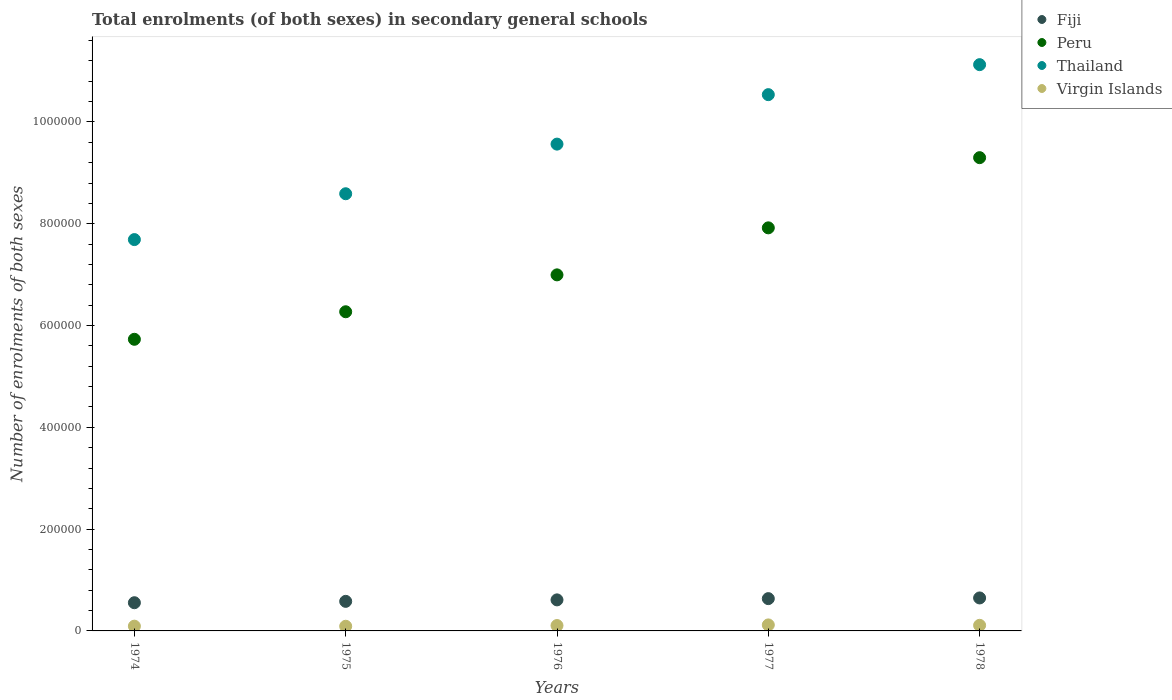How many different coloured dotlines are there?
Provide a succinct answer. 4. Is the number of dotlines equal to the number of legend labels?
Provide a succinct answer. Yes. What is the number of enrolments in secondary schools in Fiji in 1974?
Ensure brevity in your answer.  5.54e+04. Across all years, what is the maximum number of enrolments in secondary schools in Peru?
Your answer should be very brief. 9.30e+05. Across all years, what is the minimum number of enrolments in secondary schools in Peru?
Provide a succinct answer. 5.73e+05. In which year was the number of enrolments in secondary schools in Peru maximum?
Ensure brevity in your answer.  1978. In which year was the number of enrolments in secondary schools in Peru minimum?
Offer a very short reply. 1974. What is the total number of enrolments in secondary schools in Thailand in the graph?
Provide a short and direct response. 4.75e+06. What is the difference between the number of enrolments in secondary schools in Virgin Islands in 1974 and that in 1976?
Give a very brief answer. -1250. What is the difference between the number of enrolments in secondary schools in Virgin Islands in 1978 and the number of enrolments in secondary schools in Peru in 1977?
Provide a succinct answer. -7.81e+05. What is the average number of enrolments in secondary schools in Fiji per year?
Offer a very short reply. 6.05e+04. In the year 1975, what is the difference between the number of enrolments in secondary schools in Fiji and number of enrolments in secondary schools in Thailand?
Provide a short and direct response. -8.01e+05. What is the ratio of the number of enrolments in secondary schools in Thailand in 1975 to that in 1977?
Your answer should be very brief. 0.82. Is the number of enrolments in secondary schools in Thailand in 1974 less than that in 1975?
Your answer should be compact. Yes. What is the difference between the highest and the second highest number of enrolments in secondary schools in Thailand?
Your response must be concise. 5.89e+04. What is the difference between the highest and the lowest number of enrolments in secondary schools in Peru?
Offer a very short reply. 3.57e+05. Is the sum of the number of enrolments in secondary schools in Virgin Islands in 1974 and 1975 greater than the maximum number of enrolments in secondary schools in Fiji across all years?
Give a very brief answer. No. Is it the case that in every year, the sum of the number of enrolments in secondary schools in Fiji and number of enrolments in secondary schools in Peru  is greater than the number of enrolments in secondary schools in Thailand?
Your answer should be very brief. No. Does the number of enrolments in secondary schools in Peru monotonically increase over the years?
Make the answer very short. Yes. Is the number of enrolments in secondary schools in Peru strictly greater than the number of enrolments in secondary schools in Thailand over the years?
Give a very brief answer. No. What is the difference between two consecutive major ticks on the Y-axis?
Give a very brief answer. 2.00e+05. Are the values on the major ticks of Y-axis written in scientific E-notation?
Your response must be concise. No. Does the graph contain grids?
Your response must be concise. No. Where does the legend appear in the graph?
Make the answer very short. Top right. How many legend labels are there?
Your answer should be very brief. 4. How are the legend labels stacked?
Offer a terse response. Vertical. What is the title of the graph?
Ensure brevity in your answer.  Total enrolments (of both sexes) in secondary general schools. What is the label or title of the X-axis?
Keep it short and to the point. Years. What is the label or title of the Y-axis?
Offer a terse response. Number of enrolments of both sexes. What is the Number of enrolments of both sexes in Fiji in 1974?
Provide a succinct answer. 5.54e+04. What is the Number of enrolments of both sexes in Peru in 1974?
Keep it short and to the point. 5.73e+05. What is the Number of enrolments of both sexes in Thailand in 1974?
Give a very brief answer. 7.69e+05. What is the Number of enrolments of both sexes of Virgin Islands in 1974?
Make the answer very short. 9340. What is the Number of enrolments of both sexes of Fiji in 1975?
Your response must be concise. 5.81e+04. What is the Number of enrolments of both sexes in Peru in 1975?
Offer a very short reply. 6.27e+05. What is the Number of enrolments of both sexes of Thailand in 1975?
Your response must be concise. 8.59e+05. What is the Number of enrolments of both sexes of Virgin Islands in 1975?
Provide a succinct answer. 9160. What is the Number of enrolments of both sexes of Fiji in 1976?
Offer a terse response. 6.10e+04. What is the Number of enrolments of both sexes in Peru in 1976?
Offer a terse response. 7.00e+05. What is the Number of enrolments of both sexes in Thailand in 1976?
Offer a terse response. 9.56e+05. What is the Number of enrolments of both sexes of Virgin Islands in 1976?
Your response must be concise. 1.06e+04. What is the Number of enrolments of both sexes of Fiji in 1977?
Offer a terse response. 6.34e+04. What is the Number of enrolments of both sexes in Peru in 1977?
Provide a succinct answer. 7.92e+05. What is the Number of enrolments of both sexes of Thailand in 1977?
Offer a terse response. 1.05e+06. What is the Number of enrolments of both sexes of Virgin Islands in 1977?
Ensure brevity in your answer.  1.18e+04. What is the Number of enrolments of both sexes of Fiji in 1978?
Keep it short and to the point. 6.48e+04. What is the Number of enrolments of both sexes in Peru in 1978?
Provide a succinct answer. 9.30e+05. What is the Number of enrolments of both sexes of Thailand in 1978?
Make the answer very short. 1.11e+06. What is the Number of enrolments of both sexes of Virgin Islands in 1978?
Your answer should be very brief. 1.10e+04. Across all years, what is the maximum Number of enrolments of both sexes in Fiji?
Provide a short and direct response. 6.48e+04. Across all years, what is the maximum Number of enrolments of both sexes of Peru?
Keep it short and to the point. 9.30e+05. Across all years, what is the maximum Number of enrolments of both sexes in Thailand?
Provide a succinct answer. 1.11e+06. Across all years, what is the maximum Number of enrolments of both sexes of Virgin Islands?
Keep it short and to the point. 1.18e+04. Across all years, what is the minimum Number of enrolments of both sexes of Fiji?
Provide a succinct answer. 5.54e+04. Across all years, what is the minimum Number of enrolments of both sexes of Peru?
Your answer should be compact. 5.73e+05. Across all years, what is the minimum Number of enrolments of both sexes in Thailand?
Give a very brief answer. 7.69e+05. Across all years, what is the minimum Number of enrolments of both sexes in Virgin Islands?
Your answer should be very brief. 9160. What is the total Number of enrolments of both sexes in Fiji in the graph?
Ensure brevity in your answer.  3.03e+05. What is the total Number of enrolments of both sexes in Peru in the graph?
Give a very brief answer. 3.62e+06. What is the total Number of enrolments of both sexes in Thailand in the graph?
Your answer should be very brief. 4.75e+06. What is the total Number of enrolments of both sexes in Virgin Islands in the graph?
Ensure brevity in your answer.  5.19e+04. What is the difference between the Number of enrolments of both sexes of Fiji in 1974 and that in 1975?
Your answer should be very brief. -2692. What is the difference between the Number of enrolments of both sexes of Peru in 1974 and that in 1975?
Offer a terse response. -5.41e+04. What is the difference between the Number of enrolments of both sexes of Thailand in 1974 and that in 1975?
Make the answer very short. -9.01e+04. What is the difference between the Number of enrolments of both sexes in Virgin Islands in 1974 and that in 1975?
Your response must be concise. 180. What is the difference between the Number of enrolments of both sexes in Fiji in 1974 and that in 1976?
Provide a succinct answer. -5588. What is the difference between the Number of enrolments of both sexes in Peru in 1974 and that in 1976?
Keep it short and to the point. -1.27e+05. What is the difference between the Number of enrolments of both sexes in Thailand in 1974 and that in 1976?
Your answer should be very brief. -1.88e+05. What is the difference between the Number of enrolments of both sexes of Virgin Islands in 1974 and that in 1976?
Offer a very short reply. -1250. What is the difference between the Number of enrolments of both sexes in Fiji in 1974 and that in 1977?
Provide a short and direct response. -8048. What is the difference between the Number of enrolments of both sexes of Peru in 1974 and that in 1977?
Give a very brief answer. -2.19e+05. What is the difference between the Number of enrolments of both sexes of Thailand in 1974 and that in 1977?
Your response must be concise. -2.85e+05. What is the difference between the Number of enrolments of both sexes in Virgin Islands in 1974 and that in 1977?
Provide a succinct answer. -2459. What is the difference between the Number of enrolments of both sexes in Fiji in 1974 and that in 1978?
Your answer should be compact. -9384. What is the difference between the Number of enrolments of both sexes in Peru in 1974 and that in 1978?
Offer a terse response. -3.57e+05. What is the difference between the Number of enrolments of both sexes in Thailand in 1974 and that in 1978?
Provide a succinct answer. -3.44e+05. What is the difference between the Number of enrolments of both sexes in Virgin Islands in 1974 and that in 1978?
Give a very brief answer. -1660. What is the difference between the Number of enrolments of both sexes of Fiji in 1975 and that in 1976?
Give a very brief answer. -2896. What is the difference between the Number of enrolments of both sexes of Peru in 1975 and that in 1976?
Provide a succinct answer. -7.25e+04. What is the difference between the Number of enrolments of both sexes in Thailand in 1975 and that in 1976?
Your answer should be compact. -9.75e+04. What is the difference between the Number of enrolments of both sexes in Virgin Islands in 1975 and that in 1976?
Your response must be concise. -1430. What is the difference between the Number of enrolments of both sexes in Fiji in 1975 and that in 1977?
Your response must be concise. -5356. What is the difference between the Number of enrolments of both sexes in Peru in 1975 and that in 1977?
Make the answer very short. -1.65e+05. What is the difference between the Number of enrolments of both sexes of Thailand in 1975 and that in 1977?
Provide a short and direct response. -1.95e+05. What is the difference between the Number of enrolments of both sexes of Virgin Islands in 1975 and that in 1977?
Your answer should be compact. -2639. What is the difference between the Number of enrolments of both sexes in Fiji in 1975 and that in 1978?
Offer a terse response. -6692. What is the difference between the Number of enrolments of both sexes of Peru in 1975 and that in 1978?
Your answer should be very brief. -3.03e+05. What is the difference between the Number of enrolments of both sexes of Thailand in 1975 and that in 1978?
Offer a very short reply. -2.54e+05. What is the difference between the Number of enrolments of both sexes in Virgin Islands in 1975 and that in 1978?
Your answer should be compact. -1840. What is the difference between the Number of enrolments of both sexes in Fiji in 1976 and that in 1977?
Provide a short and direct response. -2460. What is the difference between the Number of enrolments of both sexes of Peru in 1976 and that in 1977?
Make the answer very short. -9.24e+04. What is the difference between the Number of enrolments of both sexes in Thailand in 1976 and that in 1977?
Give a very brief answer. -9.72e+04. What is the difference between the Number of enrolments of both sexes in Virgin Islands in 1976 and that in 1977?
Make the answer very short. -1209. What is the difference between the Number of enrolments of both sexes in Fiji in 1976 and that in 1978?
Your response must be concise. -3796. What is the difference between the Number of enrolments of both sexes in Peru in 1976 and that in 1978?
Ensure brevity in your answer.  -2.30e+05. What is the difference between the Number of enrolments of both sexes of Thailand in 1976 and that in 1978?
Your answer should be compact. -1.56e+05. What is the difference between the Number of enrolments of both sexes in Virgin Islands in 1976 and that in 1978?
Provide a succinct answer. -410. What is the difference between the Number of enrolments of both sexes of Fiji in 1977 and that in 1978?
Give a very brief answer. -1336. What is the difference between the Number of enrolments of both sexes of Peru in 1977 and that in 1978?
Offer a terse response. -1.38e+05. What is the difference between the Number of enrolments of both sexes of Thailand in 1977 and that in 1978?
Your answer should be compact. -5.89e+04. What is the difference between the Number of enrolments of both sexes in Virgin Islands in 1977 and that in 1978?
Make the answer very short. 799. What is the difference between the Number of enrolments of both sexes of Fiji in 1974 and the Number of enrolments of both sexes of Peru in 1975?
Your answer should be very brief. -5.72e+05. What is the difference between the Number of enrolments of both sexes of Fiji in 1974 and the Number of enrolments of both sexes of Thailand in 1975?
Your response must be concise. -8.04e+05. What is the difference between the Number of enrolments of both sexes of Fiji in 1974 and the Number of enrolments of both sexes of Virgin Islands in 1975?
Keep it short and to the point. 4.62e+04. What is the difference between the Number of enrolments of both sexes in Peru in 1974 and the Number of enrolments of both sexes in Thailand in 1975?
Keep it short and to the point. -2.86e+05. What is the difference between the Number of enrolments of both sexes of Peru in 1974 and the Number of enrolments of both sexes of Virgin Islands in 1975?
Your response must be concise. 5.64e+05. What is the difference between the Number of enrolments of both sexes in Thailand in 1974 and the Number of enrolments of both sexes in Virgin Islands in 1975?
Provide a short and direct response. 7.60e+05. What is the difference between the Number of enrolments of both sexes of Fiji in 1974 and the Number of enrolments of both sexes of Peru in 1976?
Give a very brief answer. -6.44e+05. What is the difference between the Number of enrolments of both sexes in Fiji in 1974 and the Number of enrolments of both sexes in Thailand in 1976?
Provide a succinct answer. -9.01e+05. What is the difference between the Number of enrolments of both sexes of Fiji in 1974 and the Number of enrolments of both sexes of Virgin Islands in 1976?
Keep it short and to the point. 4.48e+04. What is the difference between the Number of enrolments of both sexes of Peru in 1974 and the Number of enrolments of both sexes of Thailand in 1976?
Your response must be concise. -3.83e+05. What is the difference between the Number of enrolments of both sexes in Peru in 1974 and the Number of enrolments of both sexes in Virgin Islands in 1976?
Provide a succinct answer. 5.62e+05. What is the difference between the Number of enrolments of both sexes of Thailand in 1974 and the Number of enrolments of both sexes of Virgin Islands in 1976?
Your response must be concise. 7.58e+05. What is the difference between the Number of enrolments of both sexes in Fiji in 1974 and the Number of enrolments of both sexes in Peru in 1977?
Your response must be concise. -7.37e+05. What is the difference between the Number of enrolments of both sexes of Fiji in 1974 and the Number of enrolments of both sexes of Thailand in 1977?
Give a very brief answer. -9.98e+05. What is the difference between the Number of enrolments of both sexes in Fiji in 1974 and the Number of enrolments of both sexes in Virgin Islands in 1977?
Offer a very short reply. 4.36e+04. What is the difference between the Number of enrolments of both sexes in Peru in 1974 and the Number of enrolments of both sexes in Thailand in 1977?
Your answer should be compact. -4.81e+05. What is the difference between the Number of enrolments of both sexes of Peru in 1974 and the Number of enrolments of both sexes of Virgin Islands in 1977?
Give a very brief answer. 5.61e+05. What is the difference between the Number of enrolments of both sexes in Thailand in 1974 and the Number of enrolments of both sexes in Virgin Islands in 1977?
Provide a short and direct response. 7.57e+05. What is the difference between the Number of enrolments of both sexes in Fiji in 1974 and the Number of enrolments of both sexes in Peru in 1978?
Your answer should be very brief. -8.74e+05. What is the difference between the Number of enrolments of both sexes of Fiji in 1974 and the Number of enrolments of both sexes of Thailand in 1978?
Make the answer very short. -1.06e+06. What is the difference between the Number of enrolments of both sexes of Fiji in 1974 and the Number of enrolments of both sexes of Virgin Islands in 1978?
Provide a succinct answer. 4.44e+04. What is the difference between the Number of enrolments of both sexes of Peru in 1974 and the Number of enrolments of both sexes of Thailand in 1978?
Ensure brevity in your answer.  -5.40e+05. What is the difference between the Number of enrolments of both sexes of Peru in 1974 and the Number of enrolments of both sexes of Virgin Islands in 1978?
Offer a terse response. 5.62e+05. What is the difference between the Number of enrolments of both sexes in Thailand in 1974 and the Number of enrolments of both sexes in Virgin Islands in 1978?
Offer a terse response. 7.58e+05. What is the difference between the Number of enrolments of both sexes in Fiji in 1975 and the Number of enrolments of both sexes in Peru in 1976?
Offer a very short reply. -6.41e+05. What is the difference between the Number of enrolments of both sexes of Fiji in 1975 and the Number of enrolments of both sexes of Thailand in 1976?
Provide a short and direct response. -8.98e+05. What is the difference between the Number of enrolments of both sexes in Fiji in 1975 and the Number of enrolments of both sexes in Virgin Islands in 1976?
Your answer should be very brief. 4.75e+04. What is the difference between the Number of enrolments of both sexes of Peru in 1975 and the Number of enrolments of both sexes of Thailand in 1976?
Ensure brevity in your answer.  -3.29e+05. What is the difference between the Number of enrolments of both sexes of Peru in 1975 and the Number of enrolments of both sexes of Virgin Islands in 1976?
Your answer should be compact. 6.16e+05. What is the difference between the Number of enrolments of both sexes in Thailand in 1975 and the Number of enrolments of both sexes in Virgin Islands in 1976?
Your answer should be very brief. 8.48e+05. What is the difference between the Number of enrolments of both sexes of Fiji in 1975 and the Number of enrolments of both sexes of Peru in 1977?
Offer a very short reply. -7.34e+05. What is the difference between the Number of enrolments of both sexes in Fiji in 1975 and the Number of enrolments of both sexes in Thailand in 1977?
Your response must be concise. -9.96e+05. What is the difference between the Number of enrolments of both sexes of Fiji in 1975 and the Number of enrolments of both sexes of Virgin Islands in 1977?
Ensure brevity in your answer.  4.63e+04. What is the difference between the Number of enrolments of both sexes in Peru in 1975 and the Number of enrolments of both sexes in Thailand in 1977?
Provide a short and direct response. -4.27e+05. What is the difference between the Number of enrolments of both sexes of Peru in 1975 and the Number of enrolments of both sexes of Virgin Islands in 1977?
Ensure brevity in your answer.  6.15e+05. What is the difference between the Number of enrolments of both sexes of Thailand in 1975 and the Number of enrolments of both sexes of Virgin Islands in 1977?
Provide a short and direct response. 8.47e+05. What is the difference between the Number of enrolments of both sexes of Fiji in 1975 and the Number of enrolments of both sexes of Peru in 1978?
Keep it short and to the point. -8.72e+05. What is the difference between the Number of enrolments of both sexes of Fiji in 1975 and the Number of enrolments of both sexes of Thailand in 1978?
Your answer should be very brief. -1.05e+06. What is the difference between the Number of enrolments of both sexes of Fiji in 1975 and the Number of enrolments of both sexes of Virgin Islands in 1978?
Your answer should be very brief. 4.71e+04. What is the difference between the Number of enrolments of both sexes of Peru in 1975 and the Number of enrolments of both sexes of Thailand in 1978?
Provide a short and direct response. -4.85e+05. What is the difference between the Number of enrolments of both sexes of Peru in 1975 and the Number of enrolments of both sexes of Virgin Islands in 1978?
Provide a succinct answer. 6.16e+05. What is the difference between the Number of enrolments of both sexes in Thailand in 1975 and the Number of enrolments of both sexes in Virgin Islands in 1978?
Give a very brief answer. 8.48e+05. What is the difference between the Number of enrolments of both sexes of Fiji in 1976 and the Number of enrolments of both sexes of Peru in 1977?
Your response must be concise. -7.31e+05. What is the difference between the Number of enrolments of both sexes of Fiji in 1976 and the Number of enrolments of both sexes of Thailand in 1977?
Your answer should be compact. -9.93e+05. What is the difference between the Number of enrolments of both sexes of Fiji in 1976 and the Number of enrolments of both sexes of Virgin Islands in 1977?
Your response must be concise. 4.92e+04. What is the difference between the Number of enrolments of both sexes of Peru in 1976 and the Number of enrolments of both sexes of Thailand in 1977?
Your response must be concise. -3.54e+05. What is the difference between the Number of enrolments of both sexes of Peru in 1976 and the Number of enrolments of both sexes of Virgin Islands in 1977?
Provide a succinct answer. 6.88e+05. What is the difference between the Number of enrolments of both sexes in Thailand in 1976 and the Number of enrolments of both sexes in Virgin Islands in 1977?
Offer a terse response. 9.45e+05. What is the difference between the Number of enrolments of both sexes of Fiji in 1976 and the Number of enrolments of both sexes of Peru in 1978?
Give a very brief answer. -8.69e+05. What is the difference between the Number of enrolments of both sexes of Fiji in 1976 and the Number of enrolments of both sexes of Thailand in 1978?
Offer a very short reply. -1.05e+06. What is the difference between the Number of enrolments of both sexes in Fiji in 1976 and the Number of enrolments of both sexes in Virgin Islands in 1978?
Offer a very short reply. 5.00e+04. What is the difference between the Number of enrolments of both sexes in Peru in 1976 and the Number of enrolments of both sexes in Thailand in 1978?
Ensure brevity in your answer.  -4.13e+05. What is the difference between the Number of enrolments of both sexes of Peru in 1976 and the Number of enrolments of both sexes of Virgin Islands in 1978?
Provide a short and direct response. 6.89e+05. What is the difference between the Number of enrolments of both sexes of Thailand in 1976 and the Number of enrolments of both sexes of Virgin Islands in 1978?
Keep it short and to the point. 9.45e+05. What is the difference between the Number of enrolments of both sexes in Fiji in 1977 and the Number of enrolments of both sexes in Peru in 1978?
Your answer should be very brief. -8.66e+05. What is the difference between the Number of enrolments of both sexes in Fiji in 1977 and the Number of enrolments of both sexes in Thailand in 1978?
Keep it short and to the point. -1.05e+06. What is the difference between the Number of enrolments of both sexes in Fiji in 1977 and the Number of enrolments of both sexes in Virgin Islands in 1978?
Make the answer very short. 5.24e+04. What is the difference between the Number of enrolments of both sexes of Peru in 1977 and the Number of enrolments of both sexes of Thailand in 1978?
Offer a terse response. -3.21e+05. What is the difference between the Number of enrolments of both sexes of Peru in 1977 and the Number of enrolments of both sexes of Virgin Islands in 1978?
Offer a very short reply. 7.81e+05. What is the difference between the Number of enrolments of both sexes of Thailand in 1977 and the Number of enrolments of both sexes of Virgin Islands in 1978?
Your answer should be compact. 1.04e+06. What is the average Number of enrolments of both sexes in Fiji per year?
Keep it short and to the point. 6.05e+04. What is the average Number of enrolments of both sexes of Peru per year?
Your answer should be compact. 7.24e+05. What is the average Number of enrolments of both sexes of Thailand per year?
Your answer should be very brief. 9.50e+05. What is the average Number of enrolments of both sexes of Virgin Islands per year?
Your answer should be very brief. 1.04e+04. In the year 1974, what is the difference between the Number of enrolments of both sexes in Fiji and Number of enrolments of both sexes in Peru?
Your answer should be compact. -5.18e+05. In the year 1974, what is the difference between the Number of enrolments of both sexes in Fiji and Number of enrolments of both sexes in Thailand?
Offer a very short reply. -7.13e+05. In the year 1974, what is the difference between the Number of enrolments of both sexes in Fiji and Number of enrolments of both sexes in Virgin Islands?
Provide a short and direct response. 4.61e+04. In the year 1974, what is the difference between the Number of enrolments of both sexes in Peru and Number of enrolments of both sexes in Thailand?
Provide a short and direct response. -1.96e+05. In the year 1974, what is the difference between the Number of enrolments of both sexes in Peru and Number of enrolments of both sexes in Virgin Islands?
Offer a very short reply. 5.64e+05. In the year 1974, what is the difference between the Number of enrolments of both sexes of Thailand and Number of enrolments of both sexes of Virgin Islands?
Ensure brevity in your answer.  7.60e+05. In the year 1975, what is the difference between the Number of enrolments of both sexes in Fiji and Number of enrolments of both sexes in Peru?
Your answer should be compact. -5.69e+05. In the year 1975, what is the difference between the Number of enrolments of both sexes in Fiji and Number of enrolments of both sexes in Thailand?
Keep it short and to the point. -8.01e+05. In the year 1975, what is the difference between the Number of enrolments of both sexes of Fiji and Number of enrolments of both sexes of Virgin Islands?
Keep it short and to the point. 4.89e+04. In the year 1975, what is the difference between the Number of enrolments of both sexes of Peru and Number of enrolments of both sexes of Thailand?
Your response must be concise. -2.32e+05. In the year 1975, what is the difference between the Number of enrolments of both sexes in Peru and Number of enrolments of both sexes in Virgin Islands?
Ensure brevity in your answer.  6.18e+05. In the year 1975, what is the difference between the Number of enrolments of both sexes in Thailand and Number of enrolments of both sexes in Virgin Islands?
Your answer should be very brief. 8.50e+05. In the year 1976, what is the difference between the Number of enrolments of both sexes in Fiji and Number of enrolments of both sexes in Peru?
Your response must be concise. -6.39e+05. In the year 1976, what is the difference between the Number of enrolments of both sexes of Fiji and Number of enrolments of both sexes of Thailand?
Give a very brief answer. -8.95e+05. In the year 1976, what is the difference between the Number of enrolments of both sexes in Fiji and Number of enrolments of both sexes in Virgin Islands?
Make the answer very short. 5.04e+04. In the year 1976, what is the difference between the Number of enrolments of both sexes of Peru and Number of enrolments of both sexes of Thailand?
Make the answer very short. -2.57e+05. In the year 1976, what is the difference between the Number of enrolments of both sexes in Peru and Number of enrolments of both sexes in Virgin Islands?
Your response must be concise. 6.89e+05. In the year 1976, what is the difference between the Number of enrolments of both sexes of Thailand and Number of enrolments of both sexes of Virgin Islands?
Offer a very short reply. 9.46e+05. In the year 1977, what is the difference between the Number of enrolments of both sexes of Fiji and Number of enrolments of both sexes of Peru?
Offer a very short reply. -7.28e+05. In the year 1977, what is the difference between the Number of enrolments of both sexes of Fiji and Number of enrolments of both sexes of Thailand?
Provide a succinct answer. -9.90e+05. In the year 1977, what is the difference between the Number of enrolments of both sexes in Fiji and Number of enrolments of both sexes in Virgin Islands?
Give a very brief answer. 5.16e+04. In the year 1977, what is the difference between the Number of enrolments of both sexes of Peru and Number of enrolments of both sexes of Thailand?
Your answer should be compact. -2.62e+05. In the year 1977, what is the difference between the Number of enrolments of both sexes in Peru and Number of enrolments of both sexes in Virgin Islands?
Give a very brief answer. 7.80e+05. In the year 1977, what is the difference between the Number of enrolments of both sexes of Thailand and Number of enrolments of both sexes of Virgin Islands?
Keep it short and to the point. 1.04e+06. In the year 1978, what is the difference between the Number of enrolments of both sexes in Fiji and Number of enrolments of both sexes in Peru?
Provide a short and direct response. -8.65e+05. In the year 1978, what is the difference between the Number of enrolments of both sexes of Fiji and Number of enrolments of both sexes of Thailand?
Your answer should be compact. -1.05e+06. In the year 1978, what is the difference between the Number of enrolments of both sexes in Fiji and Number of enrolments of both sexes in Virgin Islands?
Your answer should be compact. 5.38e+04. In the year 1978, what is the difference between the Number of enrolments of both sexes of Peru and Number of enrolments of both sexes of Thailand?
Provide a short and direct response. -1.83e+05. In the year 1978, what is the difference between the Number of enrolments of both sexes of Peru and Number of enrolments of both sexes of Virgin Islands?
Your response must be concise. 9.19e+05. In the year 1978, what is the difference between the Number of enrolments of both sexes in Thailand and Number of enrolments of both sexes in Virgin Islands?
Your answer should be compact. 1.10e+06. What is the ratio of the Number of enrolments of both sexes in Fiji in 1974 to that in 1975?
Provide a short and direct response. 0.95. What is the ratio of the Number of enrolments of both sexes in Peru in 1974 to that in 1975?
Make the answer very short. 0.91. What is the ratio of the Number of enrolments of both sexes of Thailand in 1974 to that in 1975?
Ensure brevity in your answer.  0.9. What is the ratio of the Number of enrolments of both sexes in Virgin Islands in 1974 to that in 1975?
Offer a terse response. 1.02. What is the ratio of the Number of enrolments of both sexes of Fiji in 1974 to that in 1976?
Provide a succinct answer. 0.91. What is the ratio of the Number of enrolments of both sexes of Peru in 1974 to that in 1976?
Your answer should be compact. 0.82. What is the ratio of the Number of enrolments of both sexes of Thailand in 1974 to that in 1976?
Give a very brief answer. 0.8. What is the ratio of the Number of enrolments of both sexes of Virgin Islands in 1974 to that in 1976?
Your answer should be compact. 0.88. What is the ratio of the Number of enrolments of both sexes in Fiji in 1974 to that in 1977?
Offer a terse response. 0.87. What is the ratio of the Number of enrolments of both sexes in Peru in 1974 to that in 1977?
Your answer should be very brief. 0.72. What is the ratio of the Number of enrolments of both sexes in Thailand in 1974 to that in 1977?
Provide a short and direct response. 0.73. What is the ratio of the Number of enrolments of both sexes in Virgin Islands in 1974 to that in 1977?
Your answer should be very brief. 0.79. What is the ratio of the Number of enrolments of both sexes of Fiji in 1974 to that in 1978?
Offer a terse response. 0.86. What is the ratio of the Number of enrolments of both sexes of Peru in 1974 to that in 1978?
Your answer should be compact. 0.62. What is the ratio of the Number of enrolments of both sexes of Thailand in 1974 to that in 1978?
Ensure brevity in your answer.  0.69. What is the ratio of the Number of enrolments of both sexes in Virgin Islands in 1974 to that in 1978?
Your response must be concise. 0.85. What is the ratio of the Number of enrolments of both sexes of Fiji in 1975 to that in 1976?
Make the answer very short. 0.95. What is the ratio of the Number of enrolments of both sexes in Peru in 1975 to that in 1976?
Your response must be concise. 0.9. What is the ratio of the Number of enrolments of both sexes in Thailand in 1975 to that in 1976?
Your answer should be very brief. 0.9. What is the ratio of the Number of enrolments of both sexes of Virgin Islands in 1975 to that in 1976?
Keep it short and to the point. 0.86. What is the ratio of the Number of enrolments of both sexes of Fiji in 1975 to that in 1977?
Your response must be concise. 0.92. What is the ratio of the Number of enrolments of both sexes in Peru in 1975 to that in 1977?
Keep it short and to the point. 0.79. What is the ratio of the Number of enrolments of both sexes in Thailand in 1975 to that in 1977?
Keep it short and to the point. 0.82. What is the ratio of the Number of enrolments of both sexes of Virgin Islands in 1975 to that in 1977?
Your answer should be compact. 0.78. What is the ratio of the Number of enrolments of both sexes in Fiji in 1975 to that in 1978?
Keep it short and to the point. 0.9. What is the ratio of the Number of enrolments of both sexes in Peru in 1975 to that in 1978?
Give a very brief answer. 0.67. What is the ratio of the Number of enrolments of both sexes in Thailand in 1975 to that in 1978?
Give a very brief answer. 0.77. What is the ratio of the Number of enrolments of both sexes of Virgin Islands in 1975 to that in 1978?
Ensure brevity in your answer.  0.83. What is the ratio of the Number of enrolments of both sexes of Fiji in 1976 to that in 1977?
Offer a terse response. 0.96. What is the ratio of the Number of enrolments of both sexes of Peru in 1976 to that in 1977?
Your response must be concise. 0.88. What is the ratio of the Number of enrolments of both sexes of Thailand in 1976 to that in 1977?
Give a very brief answer. 0.91. What is the ratio of the Number of enrolments of both sexes in Virgin Islands in 1976 to that in 1977?
Keep it short and to the point. 0.9. What is the ratio of the Number of enrolments of both sexes in Fiji in 1976 to that in 1978?
Ensure brevity in your answer.  0.94. What is the ratio of the Number of enrolments of both sexes of Peru in 1976 to that in 1978?
Provide a short and direct response. 0.75. What is the ratio of the Number of enrolments of both sexes of Thailand in 1976 to that in 1978?
Offer a very short reply. 0.86. What is the ratio of the Number of enrolments of both sexes of Virgin Islands in 1976 to that in 1978?
Your answer should be compact. 0.96. What is the ratio of the Number of enrolments of both sexes of Fiji in 1977 to that in 1978?
Ensure brevity in your answer.  0.98. What is the ratio of the Number of enrolments of both sexes of Peru in 1977 to that in 1978?
Your answer should be compact. 0.85. What is the ratio of the Number of enrolments of both sexes in Thailand in 1977 to that in 1978?
Keep it short and to the point. 0.95. What is the ratio of the Number of enrolments of both sexes of Virgin Islands in 1977 to that in 1978?
Ensure brevity in your answer.  1.07. What is the difference between the highest and the second highest Number of enrolments of both sexes of Fiji?
Make the answer very short. 1336. What is the difference between the highest and the second highest Number of enrolments of both sexes in Peru?
Provide a short and direct response. 1.38e+05. What is the difference between the highest and the second highest Number of enrolments of both sexes of Thailand?
Your answer should be very brief. 5.89e+04. What is the difference between the highest and the second highest Number of enrolments of both sexes of Virgin Islands?
Give a very brief answer. 799. What is the difference between the highest and the lowest Number of enrolments of both sexes in Fiji?
Make the answer very short. 9384. What is the difference between the highest and the lowest Number of enrolments of both sexes of Peru?
Provide a short and direct response. 3.57e+05. What is the difference between the highest and the lowest Number of enrolments of both sexes of Thailand?
Ensure brevity in your answer.  3.44e+05. What is the difference between the highest and the lowest Number of enrolments of both sexes of Virgin Islands?
Give a very brief answer. 2639. 